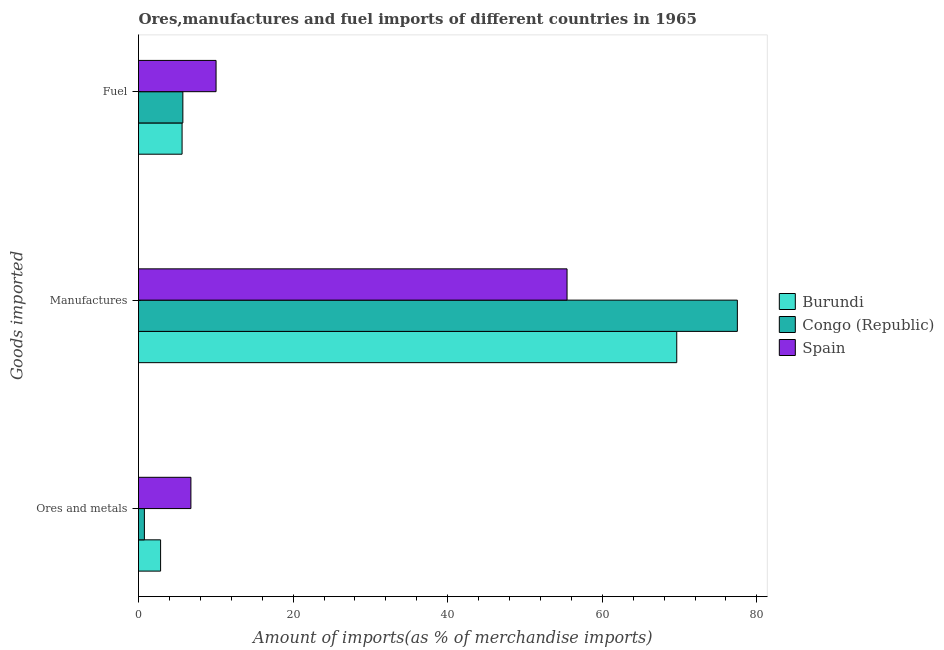How many different coloured bars are there?
Provide a short and direct response. 3. How many groups of bars are there?
Offer a terse response. 3. Are the number of bars on each tick of the Y-axis equal?
Offer a terse response. Yes. How many bars are there on the 3rd tick from the top?
Provide a short and direct response. 3. What is the label of the 2nd group of bars from the top?
Provide a succinct answer. Manufactures. What is the percentage of fuel imports in Congo (Republic)?
Your answer should be compact. 5.74. Across all countries, what is the maximum percentage of ores and metals imports?
Provide a short and direct response. 6.78. Across all countries, what is the minimum percentage of ores and metals imports?
Ensure brevity in your answer.  0.76. In which country was the percentage of manufactures imports maximum?
Provide a succinct answer. Congo (Republic). In which country was the percentage of fuel imports minimum?
Make the answer very short. Burundi. What is the total percentage of ores and metals imports in the graph?
Keep it short and to the point. 10.4. What is the difference between the percentage of ores and metals imports in Spain and that in Burundi?
Your answer should be compact. 3.92. What is the difference between the percentage of fuel imports in Spain and the percentage of ores and metals imports in Burundi?
Offer a very short reply. 7.17. What is the average percentage of ores and metals imports per country?
Ensure brevity in your answer.  3.47. What is the difference between the percentage of manufactures imports and percentage of ores and metals imports in Congo (Republic)?
Your answer should be compact. 76.72. What is the ratio of the percentage of manufactures imports in Congo (Republic) to that in Spain?
Provide a succinct answer. 1.4. What is the difference between the highest and the second highest percentage of ores and metals imports?
Provide a short and direct response. 3.92. What is the difference between the highest and the lowest percentage of manufactures imports?
Provide a short and direct response. 22.03. In how many countries, is the percentage of fuel imports greater than the average percentage of fuel imports taken over all countries?
Give a very brief answer. 1. Is the sum of the percentage of manufactures imports in Congo (Republic) and Burundi greater than the maximum percentage of ores and metals imports across all countries?
Ensure brevity in your answer.  Yes. What does the 1st bar from the top in Fuel represents?
Your response must be concise. Spain. What does the 2nd bar from the bottom in Fuel represents?
Give a very brief answer. Congo (Republic). Are all the bars in the graph horizontal?
Your answer should be compact. Yes. How many countries are there in the graph?
Give a very brief answer. 3. Are the values on the major ticks of X-axis written in scientific E-notation?
Ensure brevity in your answer.  No. Does the graph contain any zero values?
Your response must be concise. No. Where does the legend appear in the graph?
Provide a short and direct response. Center right. How many legend labels are there?
Your answer should be very brief. 3. How are the legend labels stacked?
Provide a succinct answer. Vertical. What is the title of the graph?
Your answer should be compact. Ores,manufactures and fuel imports of different countries in 1965. What is the label or title of the X-axis?
Give a very brief answer. Amount of imports(as % of merchandise imports). What is the label or title of the Y-axis?
Offer a very short reply. Goods imported. What is the Amount of imports(as % of merchandise imports) in Burundi in Ores and metals?
Your response must be concise. 2.86. What is the Amount of imports(as % of merchandise imports) in Congo (Republic) in Ores and metals?
Give a very brief answer. 0.76. What is the Amount of imports(as % of merchandise imports) in Spain in Ores and metals?
Offer a very short reply. 6.78. What is the Amount of imports(as % of merchandise imports) of Burundi in Manufactures?
Offer a very short reply. 69.64. What is the Amount of imports(as % of merchandise imports) of Congo (Republic) in Manufactures?
Provide a short and direct response. 77.48. What is the Amount of imports(as % of merchandise imports) of Spain in Manufactures?
Provide a succinct answer. 55.44. What is the Amount of imports(as % of merchandise imports) of Burundi in Fuel?
Provide a short and direct response. 5.64. What is the Amount of imports(as % of merchandise imports) in Congo (Republic) in Fuel?
Your answer should be very brief. 5.74. What is the Amount of imports(as % of merchandise imports) in Spain in Fuel?
Your response must be concise. 10.03. Across all Goods imported, what is the maximum Amount of imports(as % of merchandise imports) in Burundi?
Offer a terse response. 69.64. Across all Goods imported, what is the maximum Amount of imports(as % of merchandise imports) of Congo (Republic)?
Your answer should be very brief. 77.48. Across all Goods imported, what is the maximum Amount of imports(as % of merchandise imports) in Spain?
Ensure brevity in your answer.  55.44. Across all Goods imported, what is the minimum Amount of imports(as % of merchandise imports) of Burundi?
Your response must be concise. 2.86. Across all Goods imported, what is the minimum Amount of imports(as % of merchandise imports) in Congo (Republic)?
Offer a very short reply. 0.76. Across all Goods imported, what is the minimum Amount of imports(as % of merchandise imports) of Spain?
Offer a terse response. 6.78. What is the total Amount of imports(as % of merchandise imports) in Burundi in the graph?
Your answer should be very brief. 78.13. What is the total Amount of imports(as % of merchandise imports) in Congo (Republic) in the graph?
Keep it short and to the point. 83.98. What is the total Amount of imports(as % of merchandise imports) of Spain in the graph?
Ensure brevity in your answer.  72.26. What is the difference between the Amount of imports(as % of merchandise imports) in Burundi in Ores and metals and that in Manufactures?
Your answer should be very brief. -66.78. What is the difference between the Amount of imports(as % of merchandise imports) in Congo (Republic) in Ores and metals and that in Manufactures?
Ensure brevity in your answer.  -76.72. What is the difference between the Amount of imports(as % of merchandise imports) of Spain in Ores and metals and that in Manufactures?
Your answer should be very brief. -48.67. What is the difference between the Amount of imports(as % of merchandise imports) in Burundi in Ores and metals and that in Fuel?
Keep it short and to the point. -2.78. What is the difference between the Amount of imports(as % of merchandise imports) of Congo (Republic) in Ores and metals and that in Fuel?
Keep it short and to the point. -4.98. What is the difference between the Amount of imports(as % of merchandise imports) of Spain in Ores and metals and that in Fuel?
Offer a very short reply. -3.25. What is the difference between the Amount of imports(as % of merchandise imports) in Burundi in Manufactures and that in Fuel?
Give a very brief answer. 64. What is the difference between the Amount of imports(as % of merchandise imports) of Congo (Republic) in Manufactures and that in Fuel?
Your answer should be compact. 71.74. What is the difference between the Amount of imports(as % of merchandise imports) in Spain in Manufactures and that in Fuel?
Your response must be concise. 45.41. What is the difference between the Amount of imports(as % of merchandise imports) in Burundi in Ores and metals and the Amount of imports(as % of merchandise imports) in Congo (Republic) in Manufactures?
Keep it short and to the point. -74.62. What is the difference between the Amount of imports(as % of merchandise imports) in Burundi in Ores and metals and the Amount of imports(as % of merchandise imports) in Spain in Manufactures?
Offer a very short reply. -52.59. What is the difference between the Amount of imports(as % of merchandise imports) of Congo (Republic) in Ores and metals and the Amount of imports(as % of merchandise imports) of Spain in Manufactures?
Your response must be concise. -54.68. What is the difference between the Amount of imports(as % of merchandise imports) of Burundi in Ores and metals and the Amount of imports(as % of merchandise imports) of Congo (Republic) in Fuel?
Your answer should be compact. -2.88. What is the difference between the Amount of imports(as % of merchandise imports) in Burundi in Ores and metals and the Amount of imports(as % of merchandise imports) in Spain in Fuel?
Offer a terse response. -7.17. What is the difference between the Amount of imports(as % of merchandise imports) of Congo (Republic) in Ores and metals and the Amount of imports(as % of merchandise imports) of Spain in Fuel?
Offer a very short reply. -9.27. What is the difference between the Amount of imports(as % of merchandise imports) of Burundi in Manufactures and the Amount of imports(as % of merchandise imports) of Congo (Republic) in Fuel?
Provide a succinct answer. 63.9. What is the difference between the Amount of imports(as % of merchandise imports) in Burundi in Manufactures and the Amount of imports(as % of merchandise imports) in Spain in Fuel?
Make the answer very short. 59.61. What is the difference between the Amount of imports(as % of merchandise imports) in Congo (Republic) in Manufactures and the Amount of imports(as % of merchandise imports) in Spain in Fuel?
Offer a terse response. 67.45. What is the average Amount of imports(as % of merchandise imports) of Burundi per Goods imported?
Offer a very short reply. 26.04. What is the average Amount of imports(as % of merchandise imports) in Congo (Republic) per Goods imported?
Provide a succinct answer. 27.99. What is the average Amount of imports(as % of merchandise imports) of Spain per Goods imported?
Offer a terse response. 24.09. What is the difference between the Amount of imports(as % of merchandise imports) of Burundi and Amount of imports(as % of merchandise imports) of Congo (Republic) in Ores and metals?
Ensure brevity in your answer.  2.1. What is the difference between the Amount of imports(as % of merchandise imports) of Burundi and Amount of imports(as % of merchandise imports) of Spain in Ores and metals?
Make the answer very short. -3.92. What is the difference between the Amount of imports(as % of merchandise imports) in Congo (Republic) and Amount of imports(as % of merchandise imports) in Spain in Ores and metals?
Keep it short and to the point. -6.02. What is the difference between the Amount of imports(as % of merchandise imports) in Burundi and Amount of imports(as % of merchandise imports) in Congo (Republic) in Manufactures?
Give a very brief answer. -7.84. What is the difference between the Amount of imports(as % of merchandise imports) of Burundi and Amount of imports(as % of merchandise imports) of Spain in Manufactures?
Your answer should be very brief. 14.19. What is the difference between the Amount of imports(as % of merchandise imports) in Congo (Republic) and Amount of imports(as % of merchandise imports) in Spain in Manufactures?
Your answer should be very brief. 22.03. What is the difference between the Amount of imports(as % of merchandise imports) of Burundi and Amount of imports(as % of merchandise imports) of Congo (Republic) in Fuel?
Make the answer very short. -0.1. What is the difference between the Amount of imports(as % of merchandise imports) of Burundi and Amount of imports(as % of merchandise imports) of Spain in Fuel?
Offer a terse response. -4.4. What is the difference between the Amount of imports(as % of merchandise imports) of Congo (Republic) and Amount of imports(as % of merchandise imports) of Spain in Fuel?
Offer a very short reply. -4.3. What is the ratio of the Amount of imports(as % of merchandise imports) of Burundi in Ores and metals to that in Manufactures?
Ensure brevity in your answer.  0.04. What is the ratio of the Amount of imports(as % of merchandise imports) in Congo (Republic) in Ores and metals to that in Manufactures?
Give a very brief answer. 0.01. What is the ratio of the Amount of imports(as % of merchandise imports) in Spain in Ores and metals to that in Manufactures?
Provide a short and direct response. 0.12. What is the ratio of the Amount of imports(as % of merchandise imports) in Burundi in Ores and metals to that in Fuel?
Your response must be concise. 0.51. What is the ratio of the Amount of imports(as % of merchandise imports) of Congo (Republic) in Ores and metals to that in Fuel?
Give a very brief answer. 0.13. What is the ratio of the Amount of imports(as % of merchandise imports) in Spain in Ores and metals to that in Fuel?
Offer a terse response. 0.68. What is the ratio of the Amount of imports(as % of merchandise imports) in Burundi in Manufactures to that in Fuel?
Make the answer very short. 12.35. What is the ratio of the Amount of imports(as % of merchandise imports) in Congo (Republic) in Manufactures to that in Fuel?
Offer a terse response. 13.5. What is the ratio of the Amount of imports(as % of merchandise imports) of Spain in Manufactures to that in Fuel?
Give a very brief answer. 5.53. What is the difference between the highest and the second highest Amount of imports(as % of merchandise imports) in Burundi?
Give a very brief answer. 64. What is the difference between the highest and the second highest Amount of imports(as % of merchandise imports) of Congo (Republic)?
Offer a terse response. 71.74. What is the difference between the highest and the second highest Amount of imports(as % of merchandise imports) in Spain?
Give a very brief answer. 45.41. What is the difference between the highest and the lowest Amount of imports(as % of merchandise imports) in Burundi?
Ensure brevity in your answer.  66.78. What is the difference between the highest and the lowest Amount of imports(as % of merchandise imports) of Congo (Republic)?
Provide a short and direct response. 76.72. What is the difference between the highest and the lowest Amount of imports(as % of merchandise imports) of Spain?
Offer a terse response. 48.67. 